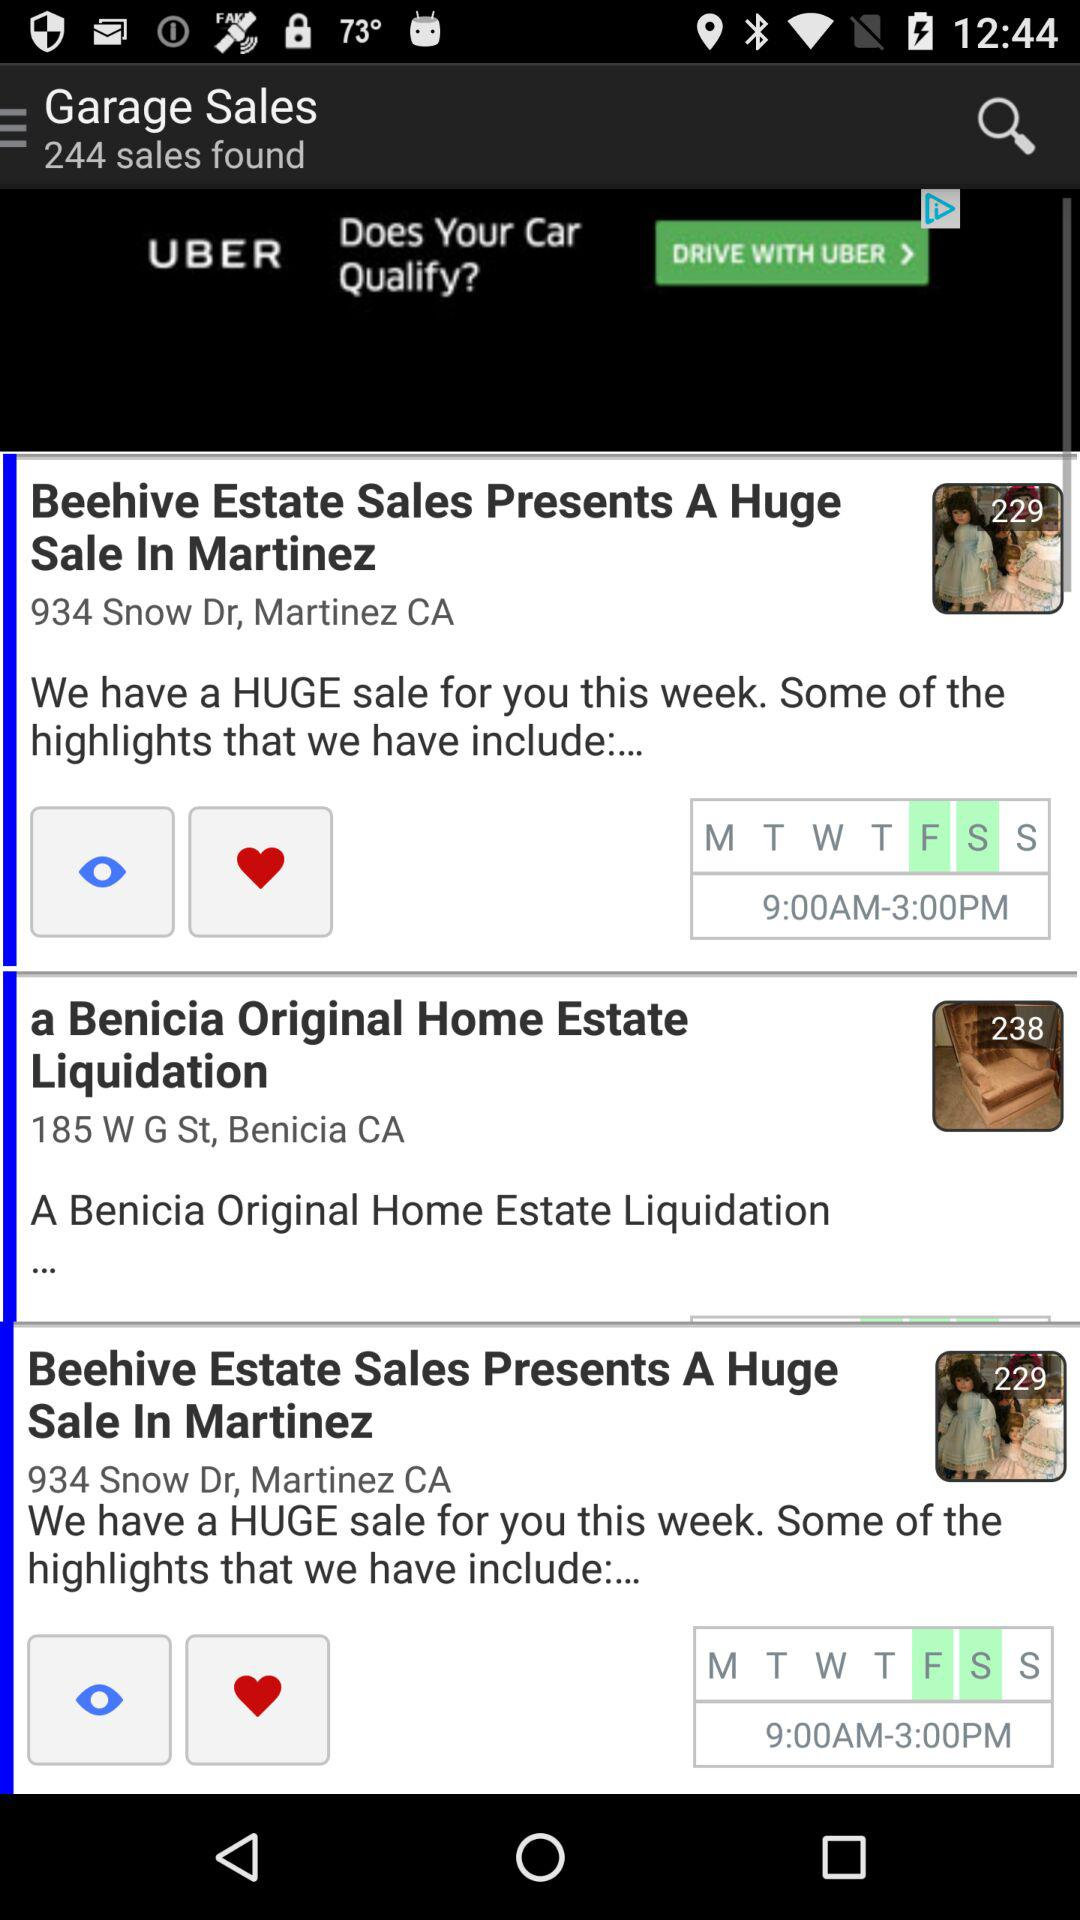What is the location of "a Benicia Original Home Estate Liquidation"? The location is 185 W G St, Benicia, CA. 